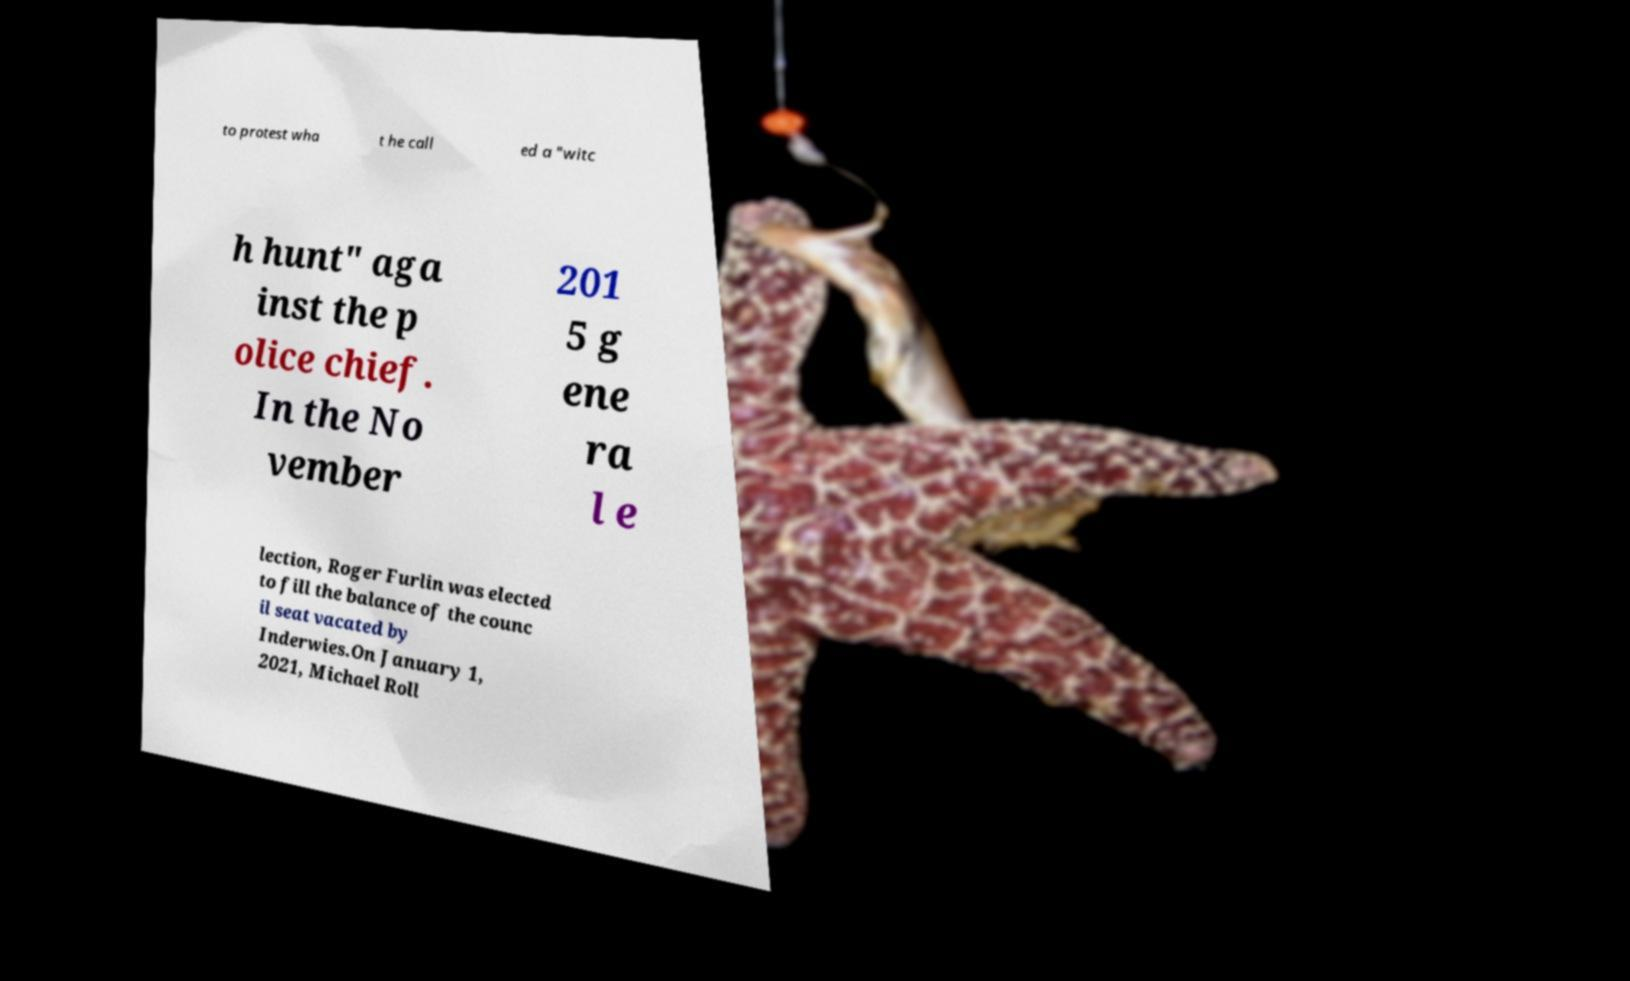Could you extract and type out the text from this image? to protest wha t he call ed a "witc h hunt" aga inst the p olice chief. In the No vember 201 5 g ene ra l e lection, Roger Furlin was elected to fill the balance of the counc il seat vacated by Inderwies.On January 1, 2021, Michael Roll 